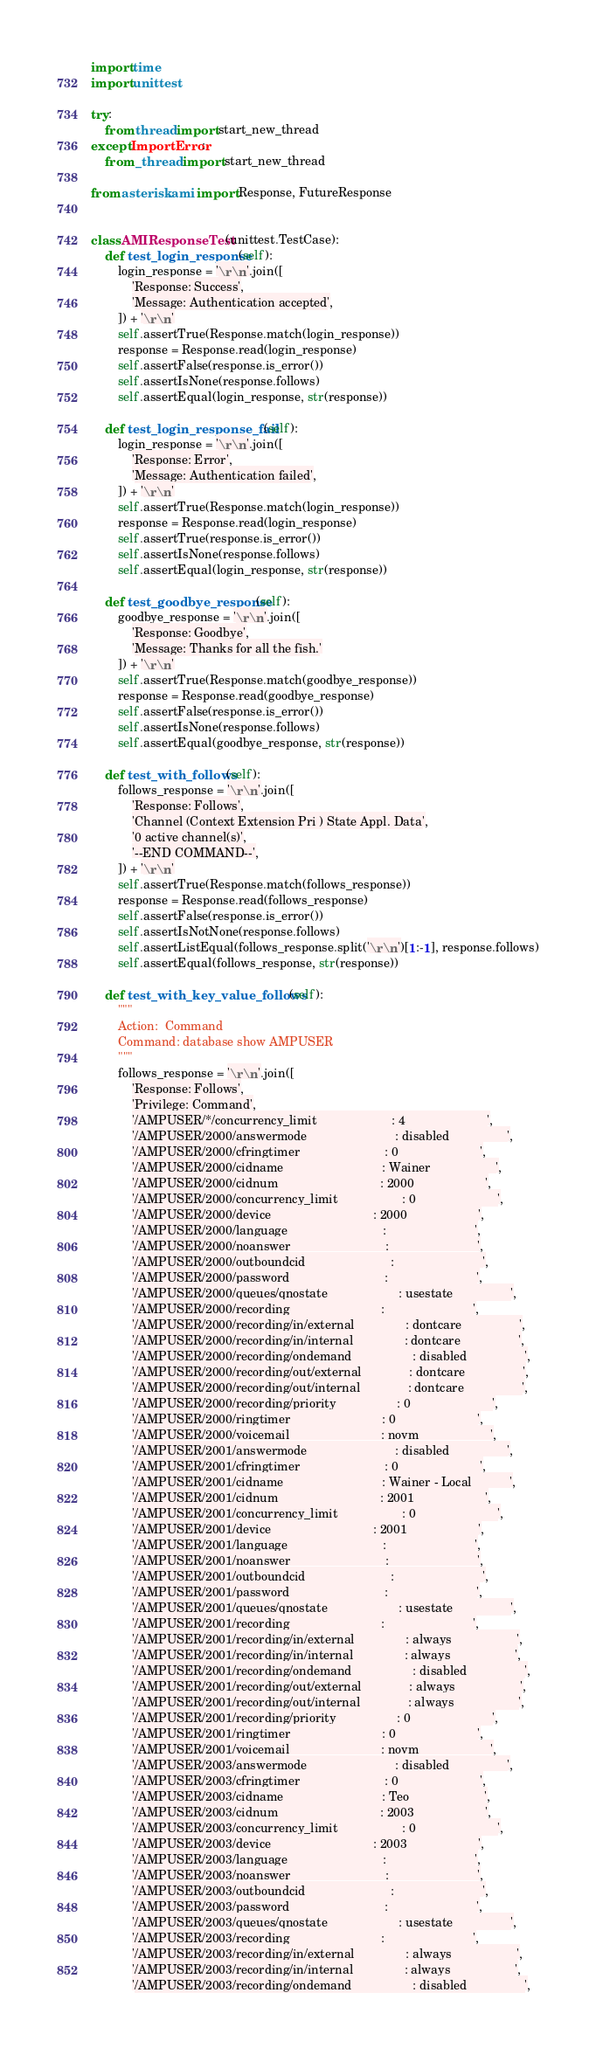Convert code to text. <code><loc_0><loc_0><loc_500><loc_500><_Python_>import time
import unittest

try:
    from thread import start_new_thread
except ImportError:
    from _thread import start_new_thread

from asterisk.ami import Response, FutureResponse


class AMIResponseTest(unittest.TestCase):
    def test_login_response(self):
        login_response = '\r\n'.join([
            'Response: Success',
            'Message: Authentication accepted',
        ]) + '\r\n'
        self.assertTrue(Response.match(login_response))
        response = Response.read(login_response)
        self.assertFalse(response.is_error())
        self.assertIsNone(response.follows)
        self.assertEqual(login_response, str(response))

    def test_login_response_fail(self):
        login_response = '\r\n'.join([
            'Response: Error',
            'Message: Authentication failed',
        ]) + '\r\n'
        self.assertTrue(Response.match(login_response))
        response = Response.read(login_response)
        self.assertTrue(response.is_error())
        self.assertIsNone(response.follows)
        self.assertEqual(login_response, str(response))

    def test_goodbye_response(self):
        goodbye_response = '\r\n'.join([
            'Response: Goodbye',
            'Message: Thanks for all the fish.'
        ]) + '\r\n'
        self.assertTrue(Response.match(goodbye_response))
        response = Response.read(goodbye_response)
        self.assertFalse(response.is_error())
        self.assertIsNone(response.follows)
        self.assertEqual(goodbye_response, str(response))

    def test_with_follows(self):
        follows_response = '\r\n'.join([
            'Response: Follows',
            'Channel (Context Extension Pri ) State Appl. Data',
            '0 active channel(s)',
            '--END COMMAND--',
        ]) + '\r\n'
        self.assertTrue(Response.match(follows_response))
        response = Response.read(follows_response)
        self.assertFalse(response.is_error())
        self.assertIsNotNone(response.follows)
        self.assertListEqual(follows_response.split('\r\n')[1:-1], response.follows)
        self.assertEqual(follows_response, str(response))

    def test_with_key_value_follows(self):
        """
        Action:  Command
        Command: database show AMPUSER
        """
        follows_response = '\r\n'.join([
            'Response: Follows',
            'Privilege: Command',
            '/AMPUSER/*/concurrency_limit                      : 4                        ',
            '/AMPUSER/2000/answermode                          : disabled                 ',
            '/AMPUSER/2000/cfringtimer                         : 0                        ',
            '/AMPUSER/2000/cidname                             : Wainer                   ',
            '/AMPUSER/2000/cidnum                              : 2000                     ',
            '/AMPUSER/2000/concurrency_limit                   : 0                        ',
            '/AMPUSER/2000/device                              : 2000                     ',
            '/AMPUSER/2000/language                            :                          ',
            '/AMPUSER/2000/noanswer                            :                          ',
            '/AMPUSER/2000/outboundcid                         :                          ',
            '/AMPUSER/2000/password                            :                          ',
            '/AMPUSER/2000/queues/qnostate                     : usestate                 ',
            '/AMPUSER/2000/recording                           :                          ',
            '/AMPUSER/2000/recording/in/external               : dontcare                 ',
            '/AMPUSER/2000/recording/in/internal               : dontcare                 ',
            '/AMPUSER/2000/recording/ondemand                  : disabled                 ',
            '/AMPUSER/2000/recording/out/external              : dontcare                 ',
            '/AMPUSER/2000/recording/out/internal              : dontcare                 ',
            '/AMPUSER/2000/recording/priority                  : 0                        ',
            '/AMPUSER/2000/ringtimer                           : 0                        ',
            '/AMPUSER/2000/voicemail                           : novm                     ',
            '/AMPUSER/2001/answermode                          : disabled                 ',
            '/AMPUSER/2001/cfringtimer                         : 0                        ',
            '/AMPUSER/2001/cidname                             : Wainer - Local           ',
            '/AMPUSER/2001/cidnum                              : 2001                     ',
            '/AMPUSER/2001/concurrency_limit                   : 0                        ',
            '/AMPUSER/2001/device                              : 2001                     ',
            '/AMPUSER/2001/language                            :                          ',
            '/AMPUSER/2001/noanswer                            :                          ',
            '/AMPUSER/2001/outboundcid                         :                          ',
            '/AMPUSER/2001/password                            :                          ',
            '/AMPUSER/2001/queues/qnostate                     : usestate                 ',
            '/AMPUSER/2001/recording                           :                          ',
            '/AMPUSER/2001/recording/in/external               : always                   ',
            '/AMPUSER/2001/recording/in/internal               : always                   ',
            '/AMPUSER/2001/recording/ondemand                  : disabled                 ',
            '/AMPUSER/2001/recording/out/external              : always                   ',
            '/AMPUSER/2001/recording/out/internal              : always                   ',
            '/AMPUSER/2001/recording/priority                  : 0                        ',
            '/AMPUSER/2001/ringtimer                           : 0                        ',
            '/AMPUSER/2001/voicemail                           : novm                     ',
            '/AMPUSER/2003/answermode                          : disabled                 ',
            '/AMPUSER/2003/cfringtimer                         : 0                        ',
            '/AMPUSER/2003/cidname                             : Teo                      ',
            '/AMPUSER/2003/cidnum                              : 2003                     ',
            '/AMPUSER/2003/concurrency_limit                   : 0                        ',
            '/AMPUSER/2003/device                              : 2003                     ',
            '/AMPUSER/2003/language                            :                          ',
            '/AMPUSER/2003/noanswer                            :                          ',
            '/AMPUSER/2003/outboundcid                         :                          ',
            '/AMPUSER/2003/password                            :                          ',
            '/AMPUSER/2003/queues/qnostate                     : usestate                 ',
            '/AMPUSER/2003/recording                           :                          ',
            '/AMPUSER/2003/recording/in/external               : always                   ',
            '/AMPUSER/2003/recording/in/internal               : always                   ',
            '/AMPUSER/2003/recording/ondemand                  : disabled                 ',</code> 